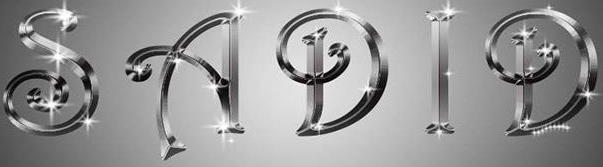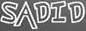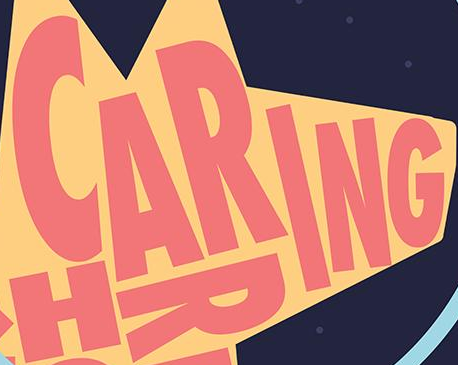What words can you see in these images in sequence, separated by a semicolon? SADID; SADID; CARING 